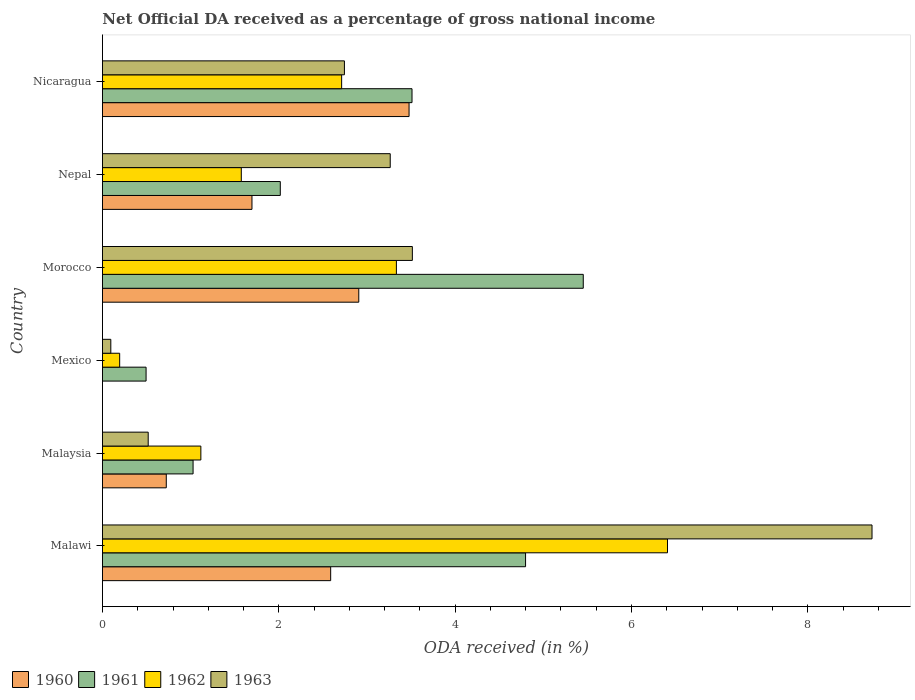Are the number of bars per tick equal to the number of legend labels?
Offer a very short reply. No. Are the number of bars on each tick of the Y-axis equal?
Keep it short and to the point. No. What is the label of the 2nd group of bars from the top?
Make the answer very short. Nepal. What is the net official DA received in 1963 in Morocco?
Provide a short and direct response. 3.51. Across all countries, what is the maximum net official DA received in 1960?
Your answer should be compact. 3.48. Across all countries, what is the minimum net official DA received in 1961?
Offer a very short reply. 0.49. In which country was the net official DA received in 1961 maximum?
Provide a short and direct response. Morocco. What is the total net official DA received in 1960 in the graph?
Give a very brief answer. 11.39. What is the difference between the net official DA received in 1960 in Malawi and that in Malaysia?
Your answer should be compact. 1.86. What is the difference between the net official DA received in 1960 in Nicaragua and the net official DA received in 1962 in Mexico?
Ensure brevity in your answer.  3.28. What is the average net official DA received in 1960 per country?
Keep it short and to the point. 1.9. What is the difference between the net official DA received in 1960 and net official DA received in 1961 in Morocco?
Ensure brevity in your answer.  -2.55. In how many countries, is the net official DA received in 1962 greater than 7.6 %?
Your answer should be very brief. 0. What is the ratio of the net official DA received in 1961 in Malaysia to that in Nicaragua?
Keep it short and to the point. 0.29. What is the difference between the highest and the second highest net official DA received in 1963?
Offer a terse response. 5.21. What is the difference between the highest and the lowest net official DA received in 1960?
Give a very brief answer. 3.48. How many bars are there?
Provide a short and direct response. 23. How many countries are there in the graph?
Your answer should be very brief. 6. Are the values on the major ticks of X-axis written in scientific E-notation?
Offer a very short reply. No. Does the graph contain grids?
Your answer should be compact. No. How many legend labels are there?
Ensure brevity in your answer.  4. What is the title of the graph?
Your answer should be compact. Net Official DA received as a percentage of gross national income. What is the label or title of the X-axis?
Your response must be concise. ODA received (in %). What is the ODA received (in %) in 1960 in Malawi?
Give a very brief answer. 2.59. What is the ODA received (in %) of 1961 in Malawi?
Provide a short and direct response. 4.8. What is the ODA received (in %) in 1962 in Malawi?
Make the answer very short. 6.41. What is the ODA received (in %) in 1963 in Malawi?
Give a very brief answer. 8.73. What is the ODA received (in %) of 1960 in Malaysia?
Keep it short and to the point. 0.72. What is the ODA received (in %) of 1961 in Malaysia?
Your response must be concise. 1.03. What is the ODA received (in %) in 1962 in Malaysia?
Give a very brief answer. 1.12. What is the ODA received (in %) of 1963 in Malaysia?
Keep it short and to the point. 0.52. What is the ODA received (in %) of 1961 in Mexico?
Provide a short and direct response. 0.49. What is the ODA received (in %) of 1962 in Mexico?
Make the answer very short. 0.2. What is the ODA received (in %) of 1963 in Mexico?
Offer a very short reply. 0.09. What is the ODA received (in %) in 1960 in Morocco?
Give a very brief answer. 2.91. What is the ODA received (in %) in 1961 in Morocco?
Provide a succinct answer. 5.45. What is the ODA received (in %) of 1962 in Morocco?
Offer a very short reply. 3.33. What is the ODA received (in %) of 1963 in Morocco?
Offer a very short reply. 3.51. What is the ODA received (in %) of 1960 in Nepal?
Your answer should be compact. 1.7. What is the ODA received (in %) of 1961 in Nepal?
Your answer should be compact. 2.02. What is the ODA received (in %) of 1962 in Nepal?
Ensure brevity in your answer.  1.57. What is the ODA received (in %) of 1963 in Nepal?
Ensure brevity in your answer.  3.26. What is the ODA received (in %) in 1960 in Nicaragua?
Ensure brevity in your answer.  3.48. What is the ODA received (in %) in 1961 in Nicaragua?
Your response must be concise. 3.51. What is the ODA received (in %) of 1962 in Nicaragua?
Provide a succinct answer. 2.71. What is the ODA received (in %) in 1963 in Nicaragua?
Your response must be concise. 2.74. Across all countries, what is the maximum ODA received (in %) of 1960?
Offer a very short reply. 3.48. Across all countries, what is the maximum ODA received (in %) in 1961?
Keep it short and to the point. 5.45. Across all countries, what is the maximum ODA received (in %) in 1962?
Provide a short and direct response. 6.41. Across all countries, what is the maximum ODA received (in %) of 1963?
Give a very brief answer. 8.73. Across all countries, what is the minimum ODA received (in %) of 1960?
Offer a very short reply. 0. Across all countries, what is the minimum ODA received (in %) of 1961?
Your answer should be compact. 0.49. Across all countries, what is the minimum ODA received (in %) of 1962?
Make the answer very short. 0.2. Across all countries, what is the minimum ODA received (in %) of 1963?
Provide a short and direct response. 0.09. What is the total ODA received (in %) of 1960 in the graph?
Offer a very short reply. 11.39. What is the total ODA received (in %) of 1961 in the graph?
Make the answer very short. 17.3. What is the total ODA received (in %) in 1962 in the graph?
Provide a succinct answer. 15.34. What is the total ODA received (in %) in 1963 in the graph?
Your response must be concise. 18.86. What is the difference between the ODA received (in %) of 1960 in Malawi and that in Malaysia?
Offer a terse response. 1.86. What is the difference between the ODA received (in %) of 1961 in Malawi and that in Malaysia?
Offer a very short reply. 3.77. What is the difference between the ODA received (in %) of 1962 in Malawi and that in Malaysia?
Provide a short and direct response. 5.29. What is the difference between the ODA received (in %) of 1963 in Malawi and that in Malaysia?
Offer a very short reply. 8.21. What is the difference between the ODA received (in %) in 1961 in Malawi and that in Mexico?
Your response must be concise. 4.3. What is the difference between the ODA received (in %) in 1962 in Malawi and that in Mexico?
Make the answer very short. 6.21. What is the difference between the ODA received (in %) of 1963 in Malawi and that in Mexico?
Provide a succinct answer. 8.63. What is the difference between the ODA received (in %) in 1960 in Malawi and that in Morocco?
Ensure brevity in your answer.  -0.32. What is the difference between the ODA received (in %) of 1961 in Malawi and that in Morocco?
Make the answer very short. -0.65. What is the difference between the ODA received (in %) in 1962 in Malawi and that in Morocco?
Provide a short and direct response. 3.08. What is the difference between the ODA received (in %) in 1963 in Malawi and that in Morocco?
Give a very brief answer. 5.21. What is the difference between the ODA received (in %) of 1960 in Malawi and that in Nepal?
Make the answer very short. 0.89. What is the difference between the ODA received (in %) of 1961 in Malawi and that in Nepal?
Your answer should be compact. 2.78. What is the difference between the ODA received (in %) in 1962 in Malawi and that in Nepal?
Offer a very short reply. 4.83. What is the difference between the ODA received (in %) in 1963 in Malawi and that in Nepal?
Offer a very short reply. 5.46. What is the difference between the ODA received (in %) of 1960 in Malawi and that in Nicaragua?
Provide a short and direct response. -0.89. What is the difference between the ODA received (in %) in 1961 in Malawi and that in Nicaragua?
Your response must be concise. 1.29. What is the difference between the ODA received (in %) of 1962 in Malawi and that in Nicaragua?
Provide a short and direct response. 3.7. What is the difference between the ODA received (in %) in 1963 in Malawi and that in Nicaragua?
Offer a very short reply. 5.98. What is the difference between the ODA received (in %) of 1961 in Malaysia and that in Mexico?
Your response must be concise. 0.53. What is the difference between the ODA received (in %) in 1962 in Malaysia and that in Mexico?
Ensure brevity in your answer.  0.92. What is the difference between the ODA received (in %) in 1963 in Malaysia and that in Mexico?
Your response must be concise. 0.42. What is the difference between the ODA received (in %) of 1960 in Malaysia and that in Morocco?
Your answer should be compact. -2.18. What is the difference between the ODA received (in %) of 1961 in Malaysia and that in Morocco?
Offer a very short reply. -4.43. What is the difference between the ODA received (in %) in 1962 in Malaysia and that in Morocco?
Your response must be concise. -2.22. What is the difference between the ODA received (in %) in 1963 in Malaysia and that in Morocco?
Your answer should be very brief. -3. What is the difference between the ODA received (in %) of 1960 in Malaysia and that in Nepal?
Provide a succinct answer. -0.97. What is the difference between the ODA received (in %) of 1961 in Malaysia and that in Nepal?
Give a very brief answer. -0.99. What is the difference between the ODA received (in %) in 1962 in Malaysia and that in Nepal?
Your answer should be very brief. -0.46. What is the difference between the ODA received (in %) in 1963 in Malaysia and that in Nepal?
Offer a terse response. -2.75. What is the difference between the ODA received (in %) in 1960 in Malaysia and that in Nicaragua?
Make the answer very short. -2.75. What is the difference between the ODA received (in %) of 1961 in Malaysia and that in Nicaragua?
Your response must be concise. -2.48. What is the difference between the ODA received (in %) of 1962 in Malaysia and that in Nicaragua?
Ensure brevity in your answer.  -1.6. What is the difference between the ODA received (in %) in 1963 in Malaysia and that in Nicaragua?
Your response must be concise. -2.23. What is the difference between the ODA received (in %) in 1961 in Mexico and that in Morocco?
Give a very brief answer. -4.96. What is the difference between the ODA received (in %) of 1962 in Mexico and that in Morocco?
Give a very brief answer. -3.14. What is the difference between the ODA received (in %) of 1963 in Mexico and that in Morocco?
Provide a short and direct response. -3.42. What is the difference between the ODA received (in %) of 1961 in Mexico and that in Nepal?
Give a very brief answer. -1.52. What is the difference between the ODA received (in %) of 1962 in Mexico and that in Nepal?
Offer a terse response. -1.38. What is the difference between the ODA received (in %) of 1963 in Mexico and that in Nepal?
Offer a terse response. -3.17. What is the difference between the ODA received (in %) in 1961 in Mexico and that in Nicaragua?
Provide a succinct answer. -3.02. What is the difference between the ODA received (in %) of 1962 in Mexico and that in Nicaragua?
Your response must be concise. -2.52. What is the difference between the ODA received (in %) of 1963 in Mexico and that in Nicaragua?
Ensure brevity in your answer.  -2.65. What is the difference between the ODA received (in %) in 1960 in Morocco and that in Nepal?
Give a very brief answer. 1.21. What is the difference between the ODA received (in %) of 1961 in Morocco and that in Nepal?
Your answer should be compact. 3.44. What is the difference between the ODA received (in %) in 1962 in Morocco and that in Nepal?
Your response must be concise. 1.76. What is the difference between the ODA received (in %) of 1963 in Morocco and that in Nepal?
Make the answer very short. 0.25. What is the difference between the ODA received (in %) of 1960 in Morocco and that in Nicaragua?
Make the answer very short. -0.57. What is the difference between the ODA received (in %) of 1961 in Morocco and that in Nicaragua?
Provide a succinct answer. 1.94. What is the difference between the ODA received (in %) in 1962 in Morocco and that in Nicaragua?
Ensure brevity in your answer.  0.62. What is the difference between the ODA received (in %) of 1963 in Morocco and that in Nicaragua?
Make the answer very short. 0.77. What is the difference between the ODA received (in %) in 1960 in Nepal and that in Nicaragua?
Provide a succinct answer. -1.78. What is the difference between the ODA received (in %) in 1961 in Nepal and that in Nicaragua?
Your answer should be compact. -1.49. What is the difference between the ODA received (in %) of 1962 in Nepal and that in Nicaragua?
Ensure brevity in your answer.  -1.14. What is the difference between the ODA received (in %) of 1963 in Nepal and that in Nicaragua?
Give a very brief answer. 0.52. What is the difference between the ODA received (in %) of 1960 in Malawi and the ODA received (in %) of 1961 in Malaysia?
Your answer should be compact. 1.56. What is the difference between the ODA received (in %) in 1960 in Malawi and the ODA received (in %) in 1962 in Malaysia?
Offer a terse response. 1.47. What is the difference between the ODA received (in %) of 1960 in Malawi and the ODA received (in %) of 1963 in Malaysia?
Your answer should be very brief. 2.07. What is the difference between the ODA received (in %) in 1961 in Malawi and the ODA received (in %) in 1962 in Malaysia?
Provide a succinct answer. 3.68. What is the difference between the ODA received (in %) in 1961 in Malawi and the ODA received (in %) in 1963 in Malaysia?
Your answer should be very brief. 4.28. What is the difference between the ODA received (in %) in 1962 in Malawi and the ODA received (in %) in 1963 in Malaysia?
Make the answer very short. 5.89. What is the difference between the ODA received (in %) in 1960 in Malawi and the ODA received (in %) in 1961 in Mexico?
Give a very brief answer. 2.09. What is the difference between the ODA received (in %) in 1960 in Malawi and the ODA received (in %) in 1962 in Mexico?
Keep it short and to the point. 2.39. What is the difference between the ODA received (in %) in 1960 in Malawi and the ODA received (in %) in 1963 in Mexico?
Keep it short and to the point. 2.49. What is the difference between the ODA received (in %) of 1961 in Malawi and the ODA received (in %) of 1962 in Mexico?
Offer a terse response. 4.6. What is the difference between the ODA received (in %) in 1961 in Malawi and the ODA received (in %) in 1963 in Mexico?
Offer a very short reply. 4.7. What is the difference between the ODA received (in %) in 1962 in Malawi and the ODA received (in %) in 1963 in Mexico?
Provide a short and direct response. 6.31. What is the difference between the ODA received (in %) in 1960 in Malawi and the ODA received (in %) in 1961 in Morocco?
Keep it short and to the point. -2.87. What is the difference between the ODA received (in %) of 1960 in Malawi and the ODA received (in %) of 1962 in Morocco?
Ensure brevity in your answer.  -0.75. What is the difference between the ODA received (in %) of 1960 in Malawi and the ODA received (in %) of 1963 in Morocco?
Give a very brief answer. -0.93. What is the difference between the ODA received (in %) in 1961 in Malawi and the ODA received (in %) in 1962 in Morocco?
Offer a very short reply. 1.47. What is the difference between the ODA received (in %) in 1961 in Malawi and the ODA received (in %) in 1963 in Morocco?
Keep it short and to the point. 1.28. What is the difference between the ODA received (in %) of 1962 in Malawi and the ODA received (in %) of 1963 in Morocco?
Ensure brevity in your answer.  2.89. What is the difference between the ODA received (in %) in 1960 in Malawi and the ODA received (in %) in 1961 in Nepal?
Provide a succinct answer. 0.57. What is the difference between the ODA received (in %) in 1960 in Malawi and the ODA received (in %) in 1962 in Nepal?
Keep it short and to the point. 1.01. What is the difference between the ODA received (in %) in 1960 in Malawi and the ODA received (in %) in 1963 in Nepal?
Offer a terse response. -0.68. What is the difference between the ODA received (in %) of 1961 in Malawi and the ODA received (in %) of 1962 in Nepal?
Keep it short and to the point. 3.22. What is the difference between the ODA received (in %) of 1961 in Malawi and the ODA received (in %) of 1963 in Nepal?
Your answer should be compact. 1.53. What is the difference between the ODA received (in %) of 1962 in Malawi and the ODA received (in %) of 1963 in Nepal?
Provide a succinct answer. 3.14. What is the difference between the ODA received (in %) of 1960 in Malawi and the ODA received (in %) of 1961 in Nicaragua?
Offer a very short reply. -0.92. What is the difference between the ODA received (in %) of 1960 in Malawi and the ODA received (in %) of 1962 in Nicaragua?
Provide a succinct answer. -0.12. What is the difference between the ODA received (in %) of 1960 in Malawi and the ODA received (in %) of 1963 in Nicaragua?
Your response must be concise. -0.16. What is the difference between the ODA received (in %) of 1961 in Malawi and the ODA received (in %) of 1962 in Nicaragua?
Offer a very short reply. 2.09. What is the difference between the ODA received (in %) in 1961 in Malawi and the ODA received (in %) in 1963 in Nicaragua?
Keep it short and to the point. 2.05. What is the difference between the ODA received (in %) in 1962 in Malawi and the ODA received (in %) in 1963 in Nicaragua?
Make the answer very short. 3.66. What is the difference between the ODA received (in %) in 1960 in Malaysia and the ODA received (in %) in 1961 in Mexico?
Your response must be concise. 0.23. What is the difference between the ODA received (in %) of 1960 in Malaysia and the ODA received (in %) of 1962 in Mexico?
Provide a succinct answer. 0.53. What is the difference between the ODA received (in %) in 1960 in Malaysia and the ODA received (in %) in 1963 in Mexico?
Your response must be concise. 0.63. What is the difference between the ODA received (in %) in 1961 in Malaysia and the ODA received (in %) in 1962 in Mexico?
Offer a very short reply. 0.83. What is the difference between the ODA received (in %) of 1961 in Malaysia and the ODA received (in %) of 1963 in Mexico?
Keep it short and to the point. 0.93. What is the difference between the ODA received (in %) in 1962 in Malaysia and the ODA received (in %) in 1963 in Mexico?
Your response must be concise. 1.02. What is the difference between the ODA received (in %) in 1960 in Malaysia and the ODA received (in %) in 1961 in Morocco?
Offer a terse response. -4.73. What is the difference between the ODA received (in %) of 1960 in Malaysia and the ODA received (in %) of 1962 in Morocco?
Ensure brevity in your answer.  -2.61. What is the difference between the ODA received (in %) in 1960 in Malaysia and the ODA received (in %) in 1963 in Morocco?
Your response must be concise. -2.79. What is the difference between the ODA received (in %) of 1961 in Malaysia and the ODA received (in %) of 1962 in Morocco?
Your answer should be very brief. -2.31. What is the difference between the ODA received (in %) in 1961 in Malaysia and the ODA received (in %) in 1963 in Morocco?
Your answer should be compact. -2.49. What is the difference between the ODA received (in %) of 1962 in Malaysia and the ODA received (in %) of 1963 in Morocco?
Offer a terse response. -2.4. What is the difference between the ODA received (in %) of 1960 in Malaysia and the ODA received (in %) of 1961 in Nepal?
Keep it short and to the point. -1.29. What is the difference between the ODA received (in %) in 1960 in Malaysia and the ODA received (in %) in 1962 in Nepal?
Offer a terse response. -0.85. What is the difference between the ODA received (in %) of 1960 in Malaysia and the ODA received (in %) of 1963 in Nepal?
Your answer should be compact. -2.54. What is the difference between the ODA received (in %) of 1961 in Malaysia and the ODA received (in %) of 1962 in Nepal?
Ensure brevity in your answer.  -0.55. What is the difference between the ODA received (in %) in 1961 in Malaysia and the ODA received (in %) in 1963 in Nepal?
Your answer should be compact. -2.24. What is the difference between the ODA received (in %) of 1962 in Malaysia and the ODA received (in %) of 1963 in Nepal?
Your response must be concise. -2.15. What is the difference between the ODA received (in %) of 1960 in Malaysia and the ODA received (in %) of 1961 in Nicaragua?
Offer a terse response. -2.79. What is the difference between the ODA received (in %) in 1960 in Malaysia and the ODA received (in %) in 1962 in Nicaragua?
Provide a succinct answer. -1.99. What is the difference between the ODA received (in %) of 1960 in Malaysia and the ODA received (in %) of 1963 in Nicaragua?
Give a very brief answer. -2.02. What is the difference between the ODA received (in %) in 1961 in Malaysia and the ODA received (in %) in 1962 in Nicaragua?
Ensure brevity in your answer.  -1.69. What is the difference between the ODA received (in %) in 1961 in Malaysia and the ODA received (in %) in 1963 in Nicaragua?
Make the answer very short. -1.72. What is the difference between the ODA received (in %) of 1962 in Malaysia and the ODA received (in %) of 1963 in Nicaragua?
Offer a very short reply. -1.63. What is the difference between the ODA received (in %) of 1961 in Mexico and the ODA received (in %) of 1962 in Morocco?
Your answer should be compact. -2.84. What is the difference between the ODA received (in %) in 1961 in Mexico and the ODA received (in %) in 1963 in Morocco?
Give a very brief answer. -3.02. What is the difference between the ODA received (in %) of 1962 in Mexico and the ODA received (in %) of 1963 in Morocco?
Your response must be concise. -3.32. What is the difference between the ODA received (in %) in 1961 in Mexico and the ODA received (in %) in 1962 in Nepal?
Offer a terse response. -1.08. What is the difference between the ODA received (in %) in 1961 in Mexico and the ODA received (in %) in 1963 in Nepal?
Your answer should be very brief. -2.77. What is the difference between the ODA received (in %) of 1962 in Mexico and the ODA received (in %) of 1963 in Nepal?
Ensure brevity in your answer.  -3.07. What is the difference between the ODA received (in %) in 1961 in Mexico and the ODA received (in %) in 1962 in Nicaragua?
Make the answer very short. -2.22. What is the difference between the ODA received (in %) of 1961 in Mexico and the ODA received (in %) of 1963 in Nicaragua?
Make the answer very short. -2.25. What is the difference between the ODA received (in %) of 1962 in Mexico and the ODA received (in %) of 1963 in Nicaragua?
Your answer should be very brief. -2.55. What is the difference between the ODA received (in %) in 1960 in Morocco and the ODA received (in %) in 1961 in Nepal?
Offer a terse response. 0.89. What is the difference between the ODA received (in %) of 1960 in Morocco and the ODA received (in %) of 1962 in Nepal?
Ensure brevity in your answer.  1.33. What is the difference between the ODA received (in %) of 1960 in Morocco and the ODA received (in %) of 1963 in Nepal?
Offer a terse response. -0.36. What is the difference between the ODA received (in %) of 1961 in Morocco and the ODA received (in %) of 1962 in Nepal?
Give a very brief answer. 3.88. What is the difference between the ODA received (in %) in 1961 in Morocco and the ODA received (in %) in 1963 in Nepal?
Provide a short and direct response. 2.19. What is the difference between the ODA received (in %) in 1962 in Morocco and the ODA received (in %) in 1963 in Nepal?
Your answer should be very brief. 0.07. What is the difference between the ODA received (in %) in 1960 in Morocco and the ODA received (in %) in 1961 in Nicaragua?
Give a very brief answer. -0.6. What is the difference between the ODA received (in %) of 1960 in Morocco and the ODA received (in %) of 1962 in Nicaragua?
Your answer should be very brief. 0.19. What is the difference between the ODA received (in %) in 1960 in Morocco and the ODA received (in %) in 1963 in Nicaragua?
Provide a succinct answer. 0.16. What is the difference between the ODA received (in %) of 1961 in Morocco and the ODA received (in %) of 1962 in Nicaragua?
Your response must be concise. 2.74. What is the difference between the ODA received (in %) in 1961 in Morocco and the ODA received (in %) in 1963 in Nicaragua?
Provide a short and direct response. 2.71. What is the difference between the ODA received (in %) in 1962 in Morocco and the ODA received (in %) in 1963 in Nicaragua?
Provide a short and direct response. 0.59. What is the difference between the ODA received (in %) in 1960 in Nepal and the ODA received (in %) in 1961 in Nicaragua?
Make the answer very short. -1.82. What is the difference between the ODA received (in %) of 1960 in Nepal and the ODA received (in %) of 1962 in Nicaragua?
Give a very brief answer. -1.02. What is the difference between the ODA received (in %) in 1960 in Nepal and the ODA received (in %) in 1963 in Nicaragua?
Make the answer very short. -1.05. What is the difference between the ODA received (in %) of 1961 in Nepal and the ODA received (in %) of 1962 in Nicaragua?
Your answer should be compact. -0.7. What is the difference between the ODA received (in %) of 1961 in Nepal and the ODA received (in %) of 1963 in Nicaragua?
Give a very brief answer. -0.73. What is the difference between the ODA received (in %) of 1962 in Nepal and the ODA received (in %) of 1963 in Nicaragua?
Give a very brief answer. -1.17. What is the average ODA received (in %) of 1960 per country?
Your response must be concise. 1.9. What is the average ODA received (in %) of 1961 per country?
Provide a short and direct response. 2.88. What is the average ODA received (in %) of 1962 per country?
Provide a succinct answer. 2.56. What is the average ODA received (in %) in 1963 per country?
Provide a succinct answer. 3.14. What is the difference between the ODA received (in %) in 1960 and ODA received (in %) in 1961 in Malawi?
Make the answer very short. -2.21. What is the difference between the ODA received (in %) of 1960 and ODA received (in %) of 1962 in Malawi?
Your answer should be compact. -3.82. What is the difference between the ODA received (in %) in 1960 and ODA received (in %) in 1963 in Malawi?
Make the answer very short. -6.14. What is the difference between the ODA received (in %) in 1961 and ODA received (in %) in 1962 in Malawi?
Offer a very short reply. -1.61. What is the difference between the ODA received (in %) of 1961 and ODA received (in %) of 1963 in Malawi?
Offer a very short reply. -3.93. What is the difference between the ODA received (in %) of 1962 and ODA received (in %) of 1963 in Malawi?
Offer a very short reply. -2.32. What is the difference between the ODA received (in %) in 1960 and ODA received (in %) in 1961 in Malaysia?
Offer a terse response. -0.3. What is the difference between the ODA received (in %) in 1960 and ODA received (in %) in 1962 in Malaysia?
Make the answer very short. -0.39. What is the difference between the ODA received (in %) in 1960 and ODA received (in %) in 1963 in Malaysia?
Make the answer very short. 0.21. What is the difference between the ODA received (in %) of 1961 and ODA received (in %) of 1962 in Malaysia?
Your response must be concise. -0.09. What is the difference between the ODA received (in %) in 1961 and ODA received (in %) in 1963 in Malaysia?
Offer a very short reply. 0.51. What is the difference between the ODA received (in %) of 1962 and ODA received (in %) of 1963 in Malaysia?
Keep it short and to the point. 0.6. What is the difference between the ODA received (in %) of 1961 and ODA received (in %) of 1962 in Mexico?
Give a very brief answer. 0.3. What is the difference between the ODA received (in %) in 1962 and ODA received (in %) in 1963 in Mexico?
Give a very brief answer. 0.1. What is the difference between the ODA received (in %) of 1960 and ODA received (in %) of 1961 in Morocco?
Give a very brief answer. -2.55. What is the difference between the ODA received (in %) of 1960 and ODA received (in %) of 1962 in Morocco?
Give a very brief answer. -0.43. What is the difference between the ODA received (in %) in 1960 and ODA received (in %) in 1963 in Morocco?
Offer a terse response. -0.61. What is the difference between the ODA received (in %) in 1961 and ODA received (in %) in 1962 in Morocco?
Provide a succinct answer. 2.12. What is the difference between the ODA received (in %) in 1961 and ODA received (in %) in 1963 in Morocco?
Provide a short and direct response. 1.94. What is the difference between the ODA received (in %) of 1962 and ODA received (in %) of 1963 in Morocco?
Provide a short and direct response. -0.18. What is the difference between the ODA received (in %) in 1960 and ODA received (in %) in 1961 in Nepal?
Keep it short and to the point. -0.32. What is the difference between the ODA received (in %) in 1960 and ODA received (in %) in 1962 in Nepal?
Provide a short and direct response. 0.12. What is the difference between the ODA received (in %) of 1960 and ODA received (in %) of 1963 in Nepal?
Keep it short and to the point. -1.57. What is the difference between the ODA received (in %) of 1961 and ODA received (in %) of 1962 in Nepal?
Offer a terse response. 0.44. What is the difference between the ODA received (in %) of 1961 and ODA received (in %) of 1963 in Nepal?
Offer a very short reply. -1.25. What is the difference between the ODA received (in %) of 1962 and ODA received (in %) of 1963 in Nepal?
Offer a terse response. -1.69. What is the difference between the ODA received (in %) in 1960 and ODA received (in %) in 1961 in Nicaragua?
Provide a short and direct response. -0.03. What is the difference between the ODA received (in %) in 1960 and ODA received (in %) in 1962 in Nicaragua?
Your answer should be very brief. 0.76. What is the difference between the ODA received (in %) in 1960 and ODA received (in %) in 1963 in Nicaragua?
Give a very brief answer. 0.73. What is the difference between the ODA received (in %) in 1961 and ODA received (in %) in 1962 in Nicaragua?
Give a very brief answer. 0.8. What is the difference between the ODA received (in %) in 1961 and ODA received (in %) in 1963 in Nicaragua?
Offer a very short reply. 0.77. What is the difference between the ODA received (in %) of 1962 and ODA received (in %) of 1963 in Nicaragua?
Your answer should be very brief. -0.03. What is the ratio of the ODA received (in %) in 1960 in Malawi to that in Malaysia?
Your answer should be compact. 3.58. What is the ratio of the ODA received (in %) of 1961 in Malawi to that in Malaysia?
Provide a short and direct response. 4.67. What is the ratio of the ODA received (in %) of 1962 in Malawi to that in Malaysia?
Offer a terse response. 5.74. What is the ratio of the ODA received (in %) in 1963 in Malawi to that in Malaysia?
Make the answer very short. 16.83. What is the ratio of the ODA received (in %) in 1961 in Malawi to that in Mexico?
Offer a very short reply. 9.7. What is the ratio of the ODA received (in %) of 1962 in Malawi to that in Mexico?
Provide a short and direct response. 32.85. What is the ratio of the ODA received (in %) in 1963 in Malawi to that in Mexico?
Offer a very short reply. 92.18. What is the ratio of the ODA received (in %) in 1960 in Malawi to that in Morocco?
Give a very brief answer. 0.89. What is the ratio of the ODA received (in %) in 1962 in Malawi to that in Morocco?
Offer a terse response. 1.92. What is the ratio of the ODA received (in %) in 1963 in Malawi to that in Morocco?
Your answer should be compact. 2.48. What is the ratio of the ODA received (in %) of 1960 in Malawi to that in Nepal?
Your answer should be very brief. 1.53. What is the ratio of the ODA received (in %) in 1961 in Malawi to that in Nepal?
Make the answer very short. 2.38. What is the ratio of the ODA received (in %) in 1962 in Malawi to that in Nepal?
Offer a very short reply. 4.07. What is the ratio of the ODA received (in %) in 1963 in Malawi to that in Nepal?
Your response must be concise. 2.67. What is the ratio of the ODA received (in %) of 1960 in Malawi to that in Nicaragua?
Your answer should be very brief. 0.74. What is the ratio of the ODA received (in %) in 1961 in Malawi to that in Nicaragua?
Offer a terse response. 1.37. What is the ratio of the ODA received (in %) in 1962 in Malawi to that in Nicaragua?
Make the answer very short. 2.36. What is the ratio of the ODA received (in %) in 1963 in Malawi to that in Nicaragua?
Keep it short and to the point. 3.18. What is the ratio of the ODA received (in %) in 1961 in Malaysia to that in Mexico?
Provide a succinct answer. 2.08. What is the ratio of the ODA received (in %) in 1962 in Malaysia to that in Mexico?
Your answer should be very brief. 5.72. What is the ratio of the ODA received (in %) of 1963 in Malaysia to that in Mexico?
Offer a very short reply. 5.48. What is the ratio of the ODA received (in %) in 1960 in Malaysia to that in Morocco?
Your answer should be compact. 0.25. What is the ratio of the ODA received (in %) in 1961 in Malaysia to that in Morocco?
Give a very brief answer. 0.19. What is the ratio of the ODA received (in %) in 1962 in Malaysia to that in Morocco?
Provide a short and direct response. 0.33. What is the ratio of the ODA received (in %) of 1963 in Malaysia to that in Morocco?
Provide a short and direct response. 0.15. What is the ratio of the ODA received (in %) of 1960 in Malaysia to that in Nepal?
Provide a short and direct response. 0.43. What is the ratio of the ODA received (in %) in 1961 in Malaysia to that in Nepal?
Provide a succinct answer. 0.51. What is the ratio of the ODA received (in %) in 1962 in Malaysia to that in Nepal?
Offer a terse response. 0.71. What is the ratio of the ODA received (in %) of 1963 in Malaysia to that in Nepal?
Offer a very short reply. 0.16. What is the ratio of the ODA received (in %) in 1960 in Malaysia to that in Nicaragua?
Provide a short and direct response. 0.21. What is the ratio of the ODA received (in %) in 1961 in Malaysia to that in Nicaragua?
Your answer should be very brief. 0.29. What is the ratio of the ODA received (in %) of 1962 in Malaysia to that in Nicaragua?
Your answer should be compact. 0.41. What is the ratio of the ODA received (in %) of 1963 in Malaysia to that in Nicaragua?
Offer a terse response. 0.19. What is the ratio of the ODA received (in %) of 1961 in Mexico to that in Morocco?
Give a very brief answer. 0.09. What is the ratio of the ODA received (in %) in 1962 in Mexico to that in Morocco?
Give a very brief answer. 0.06. What is the ratio of the ODA received (in %) in 1963 in Mexico to that in Morocco?
Offer a terse response. 0.03. What is the ratio of the ODA received (in %) of 1961 in Mexico to that in Nepal?
Provide a short and direct response. 0.25. What is the ratio of the ODA received (in %) in 1962 in Mexico to that in Nepal?
Provide a short and direct response. 0.12. What is the ratio of the ODA received (in %) in 1963 in Mexico to that in Nepal?
Give a very brief answer. 0.03. What is the ratio of the ODA received (in %) of 1961 in Mexico to that in Nicaragua?
Ensure brevity in your answer.  0.14. What is the ratio of the ODA received (in %) in 1962 in Mexico to that in Nicaragua?
Your answer should be very brief. 0.07. What is the ratio of the ODA received (in %) in 1963 in Mexico to that in Nicaragua?
Your answer should be very brief. 0.03. What is the ratio of the ODA received (in %) in 1960 in Morocco to that in Nepal?
Provide a short and direct response. 1.71. What is the ratio of the ODA received (in %) in 1961 in Morocco to that in Nepal?
Your answer should be very brief. 2.7. What is the ratio of the ODA received (in %) of 1962 in Morocco to that in Nepal?
Keep it short and to the point. 2.12. What is the ratio of the ODA received (in %) of 1963 in Morocco to that in Nepal?
Ensure brevity in your answer.  1.08. What is the ratio of the ODA received (in %) of 1960 in Morocco to that in Nicaragua?
Give a very brief answer. 0.84. What is the ratio of the ODA received (in %) in 1961 in Morocco to that in Nicaragua?
Make the answer very short. 1.55. What is the ratio of the ODA received (in %) of 1962 in Morocco to that in Nicaragua?
Your answer should be compact. 1.23. What is the ratio of the ODA received (in %) in 1963 in Morocco to that in Nicaragua?
Ensure brevity in your answer.  1.28. What is the ratio of the ODA received (in %) of 1960 in Nepal to that in Nicaragua?
Your answer should be very brief. 0.49. What is the ratio of the ODA received (in %) in 1961 in Nepal to that in Nicaragua?
Offer a terse response. 0.57. What is the ratio of the ODA received (in %) in 1962 in Nepal to that in Nicaragua?
Provide a succinct answer. 0.58. What is the ratio of the ODA received (in %) of 1963 in Nepal to that in Nicaragua?
Offer a very short reply. 1.19. What is the difference between the highest and the second highest ODA received (in %) of 1960?
Keep it short and to the point. 0.57. What is the difference between the highest and the second highest ODA received (in %) in 1961?
Give a very brief answer. 0.65. What is the difference between the highest and the second highest ODA received (in %) of 1962?
Your answer should be compact. 3.08. What is the difference between the highest and the second highest ODA received (in %) in 1963?
Give a very brief answer. 5.21. What is the difference between the highest and the lowest ODA received (in %) in 1960?
Your answer should be very brief. 3.48. What is the difference between the highest and the lowest ODA received (in %) of 1961?
Give a very brief answer. 4.96. What is the difference between the highest and the lowest ODA received (in %) in 1962?
Keep it short and to the point. 6.21. What is the difference between the highest and the lowest ODA received (in %) in 1963?
Keep it short and to the point. 8.63. 